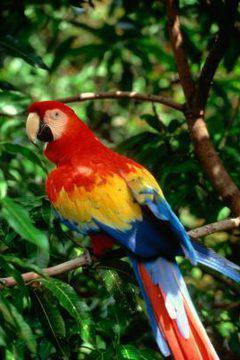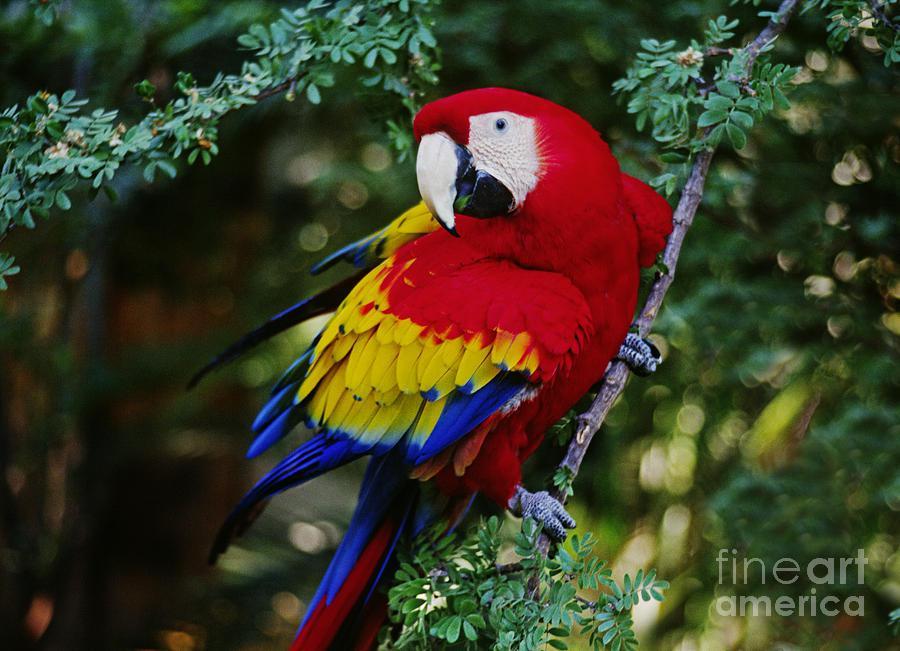The first image is the image on the left, the second image is the image on the right. For the images shown, is this caption "A parrot is eating something in at least one of the images." true? Answer yes or no. No. The first image is the image on the left, the second image is the image on the right. Analyze the images presented: Is the assertion "At least one image shows a red-headed parrot lifting a kind of nut with one claw towards its beak." valid? Answer yes or no. No. 